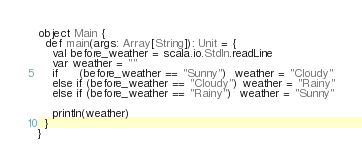Convert code to text. <code><loc_0><loc_0><loc_500><loc_500><_Scala_>object Main {
  def main(args: Array[String]): Unit = {
    val before_weather = scala.io.StdIn.readLine
    var weather = ""
    if      (before_weather == "Sunny")  weather = "Cloudy"
    else if (before_weather == "Cloudy") weather = "Rainy"
    else if (before_weather == "Rainy")  weather = "Sunny"

    println(weather)
  }
}</code> 